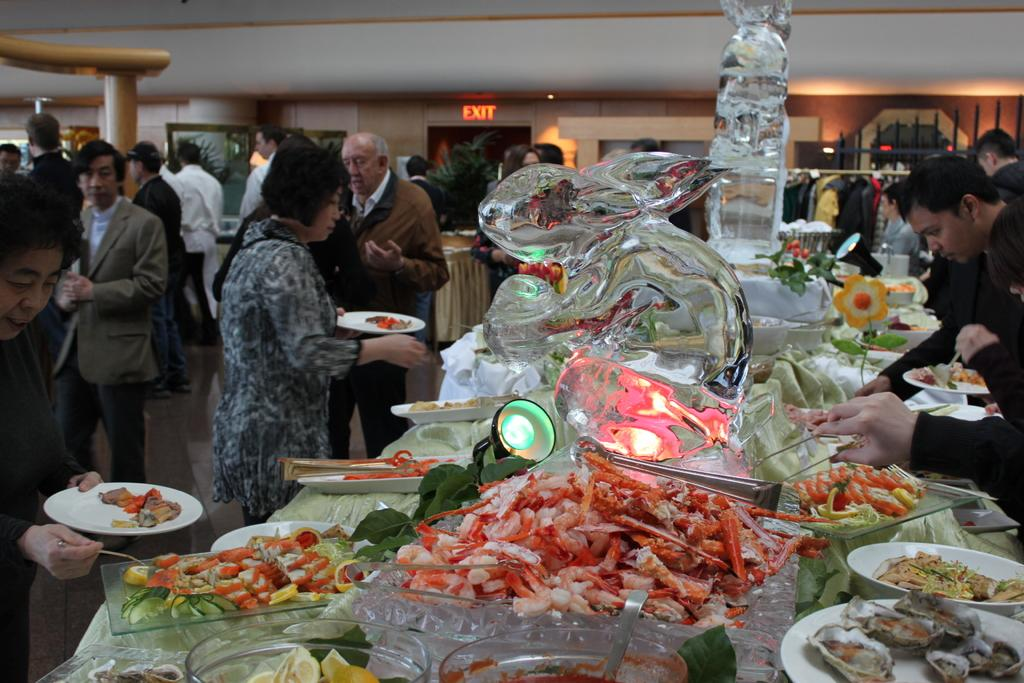What is the shape of the glass in the image? The glass in the image is in the shape of a rabbit. What else can be seen in the image besides the rabbit-shaped glass? There are food items in the image. Where are the people located in the image? The people are standing on the left side of the image. What type of wrench is being used to adjust the nose of the goldfish in the image? There is no wrench, nose, or goldfish present in the image. 